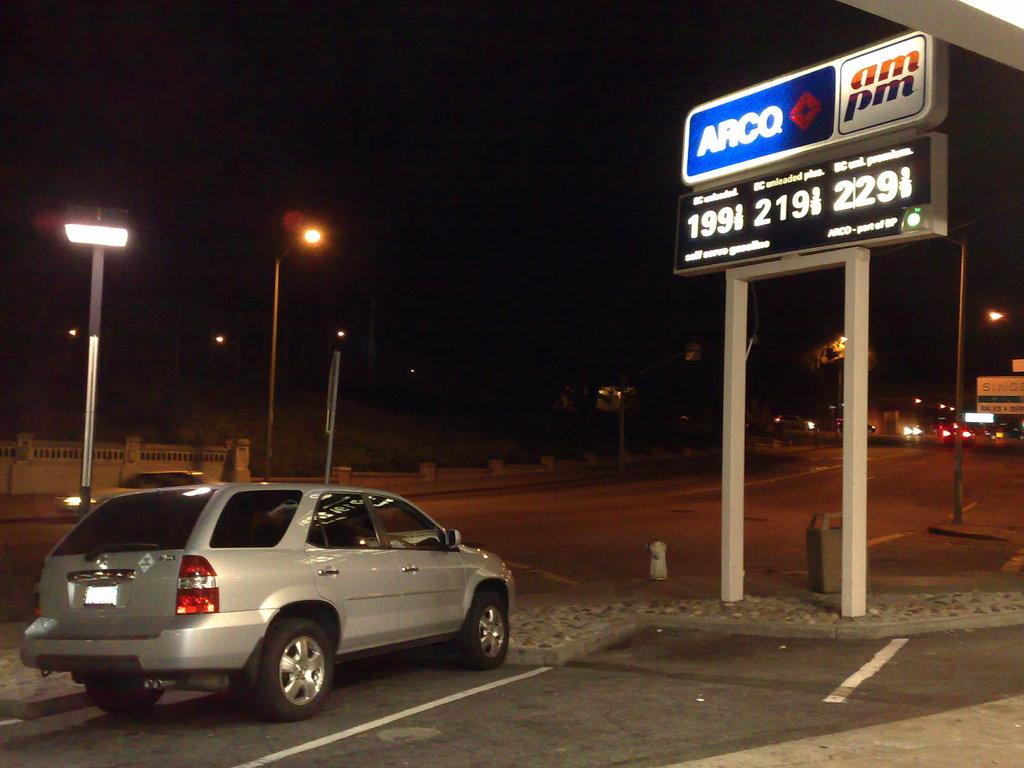What is the main subject of the image? The main subject of the image is a car on the road. What else can be seen in the image besides the car? There are boards with text and numbers, poles, street lights, and a wall visible in the image. What is the condition of the background in the image? The background of the image is dark. What type of button can be seen on the car's dashboard in the image? There is no button visible on the car's dashboard in the image. What is the income of the person driving the car in the image? There is no information about the person driving the car or their income in the image. 